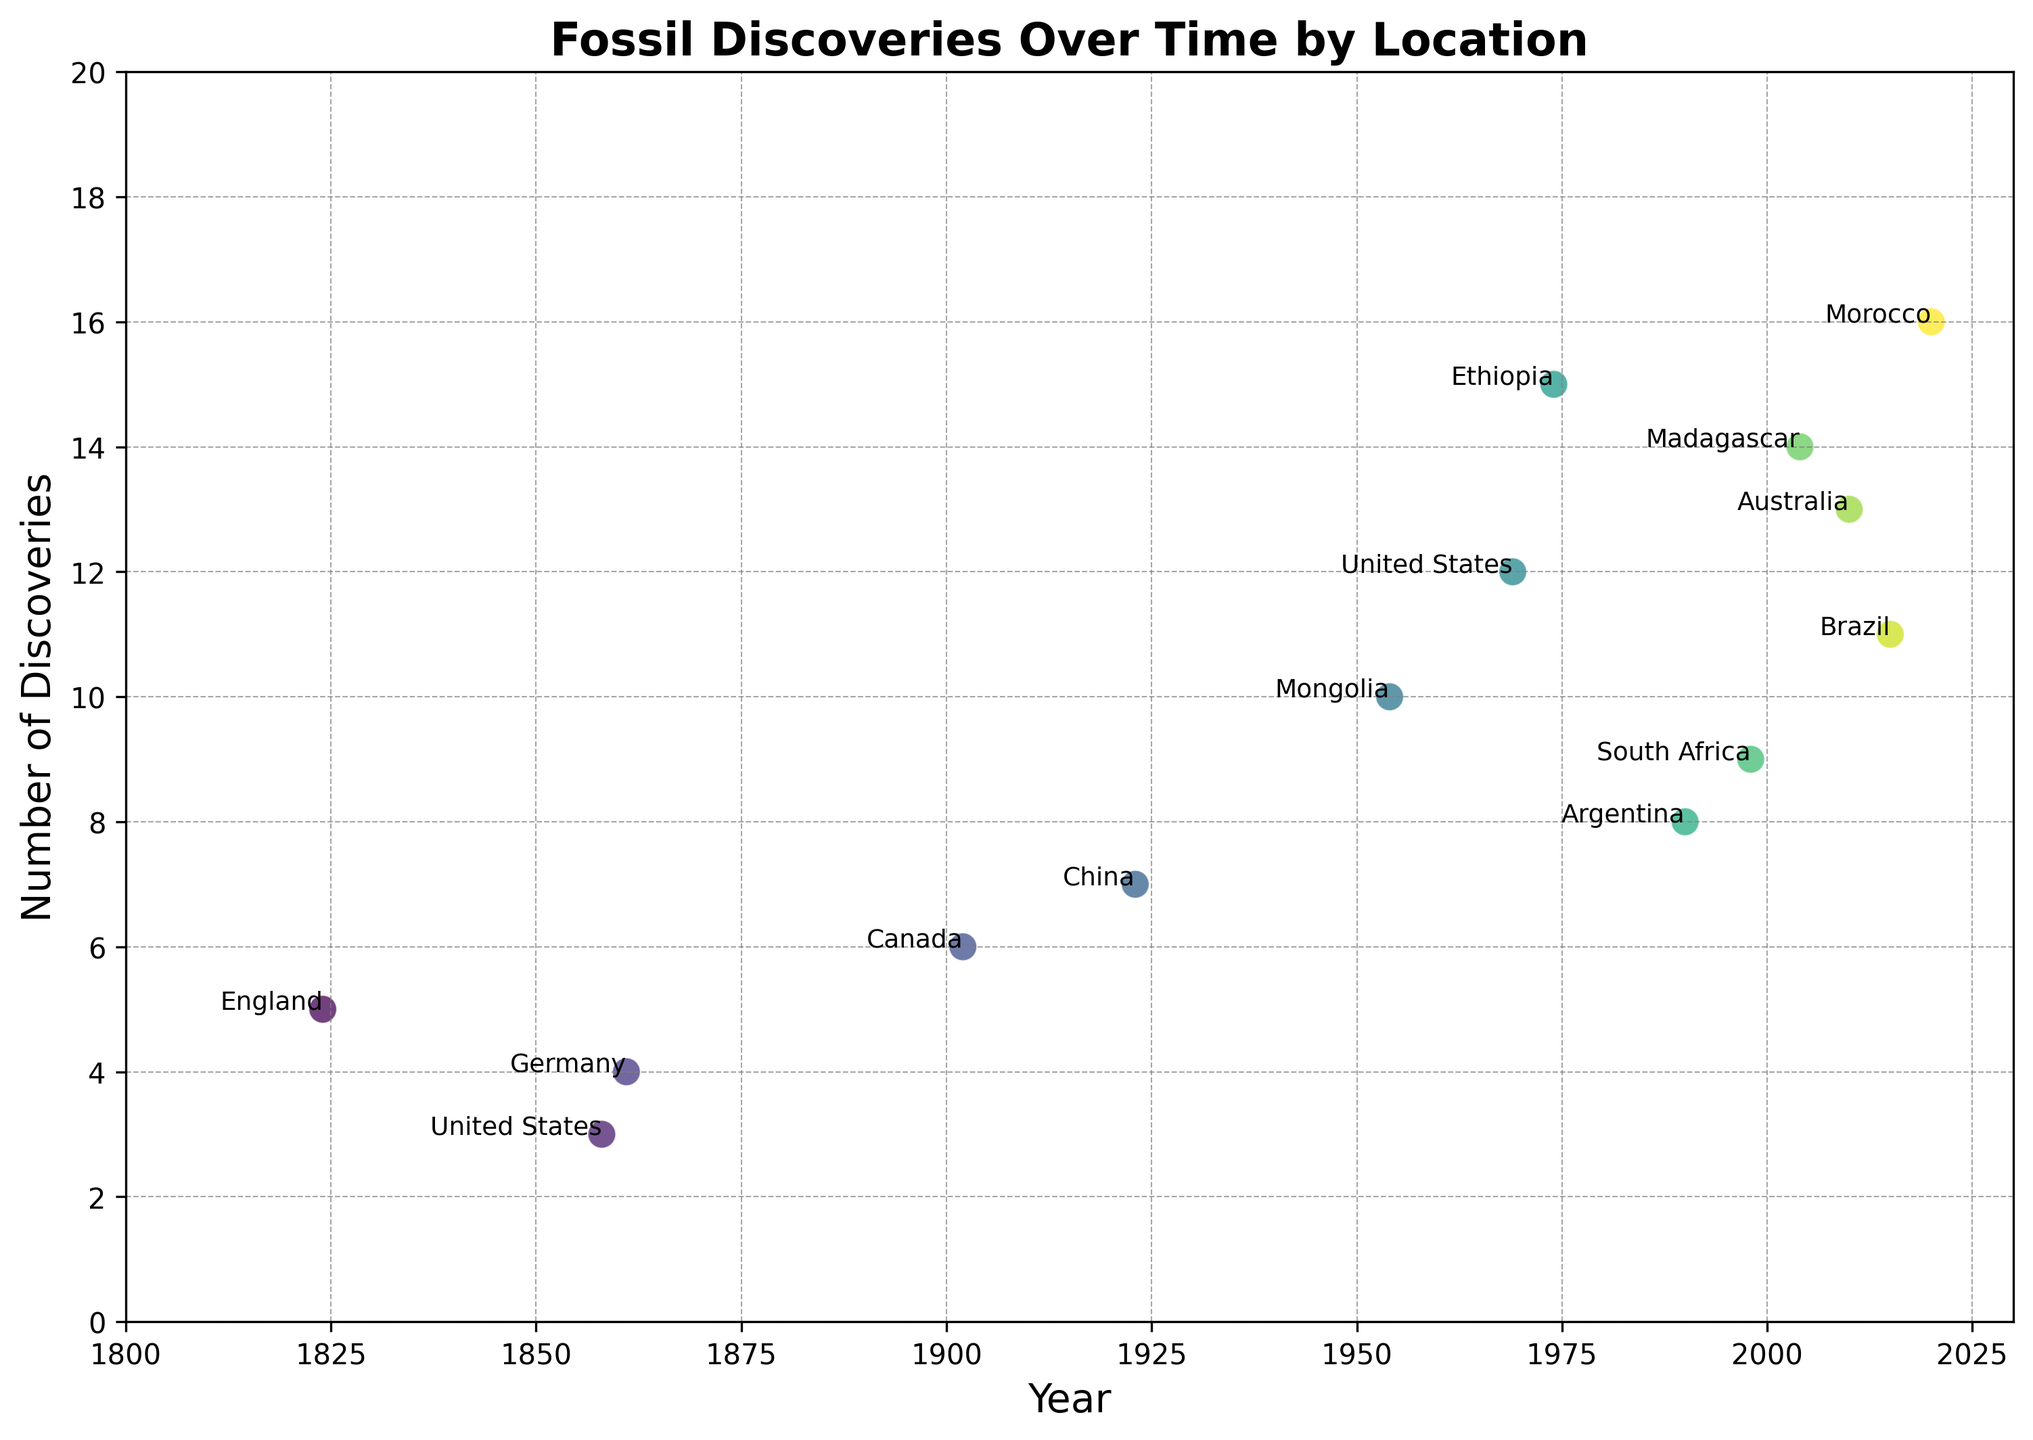Which location had the highest number of fossil discoveries in 2020? Look at the data point for the year 2020 and check the label for the corresponding location with the highest number of discoveries.
Answer: Morocco How many years had at least 10 fossil discoveries? Count the data points on the plot where the number of discoveries is 10 or more.
Answer: 7 Between 1954 and 1974, which country's discoveries increased the most? Identify the data points for 1954 and 1974, referring to Mongolia and Ethiopia, respectively. Calculate the change in discoveries from 1954 to 1974. From 10 in 1954 to 15 in 1974, the increase is 5.
Answer: Ethiopia What is the median number of fossil discoveries for the locations shown? List the number of discoveries for all locations, sort them, and find the middle value. The values are: 3, 4, 5, 6, 7, 8, 9, 10, 11, 12, 13, 14, 15, 16. The median is the middle value in this sorted list.
Answer: 10 Which country's discoveries decreased from one year to another, and by how much? Compare the data points for each location year over year to find where the number decreased. United States from 1858 (3) to 1969 (12) is the initial increase, but not an answer here. All other points either increase or remain stable.
Answer: None What is the average number of fossil discoveries in the 2000s? Only consider the data points from 2004, 2010, and 2015 for Madagascar, Australia, and Brazil with discoveries 14, 13, and 11 respectively. Calculate the average: (14 + 13 + 11) / 3 = 12.67.
Answer: 12.67 How do fossil discoveries in England (1824) compare to those in Germany (1861)? Look at the discoveries for the years 1824 and 1861 which correspond to England and Germany respectively. Compare the values: 5 for England and 4 for Germany.
Answer: England had 1 more discovery What is the trend of discoveries over time for the United States? Identify the data points for the United States: 1858 (3 discoveries) and 1969 (12 discoveries). The number increases from 3 to 12 over these years.
Answer: Increasing Which year had the highest number of discoveries and which location was it? Look for the data point with the highest value on the y-axis (number of discoveries). Note the corresponding year and location.
Answer: 2020, Morocco 